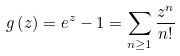Convert formula to latex. <formula><loc_0><loc_0><loc_500><loc_500>g \left ( z \right ) = e ^ { z } - 1 = \sum _ { n \geq 1 } \frac { z ^ { n } } { n ! }</formula> 